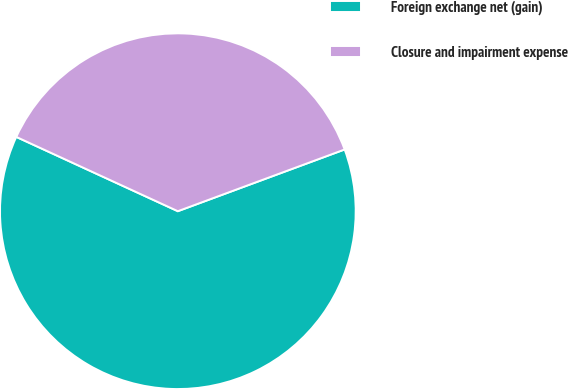Convert chart. <chart><loc_0><loc_0><loc_500><loc_500><pie_chart><fcel>Foreign exchange net (gain)<fcel>Closure and impairment expense<nl><fcel>62.5%<fcel>37.5%<nl></chart> 